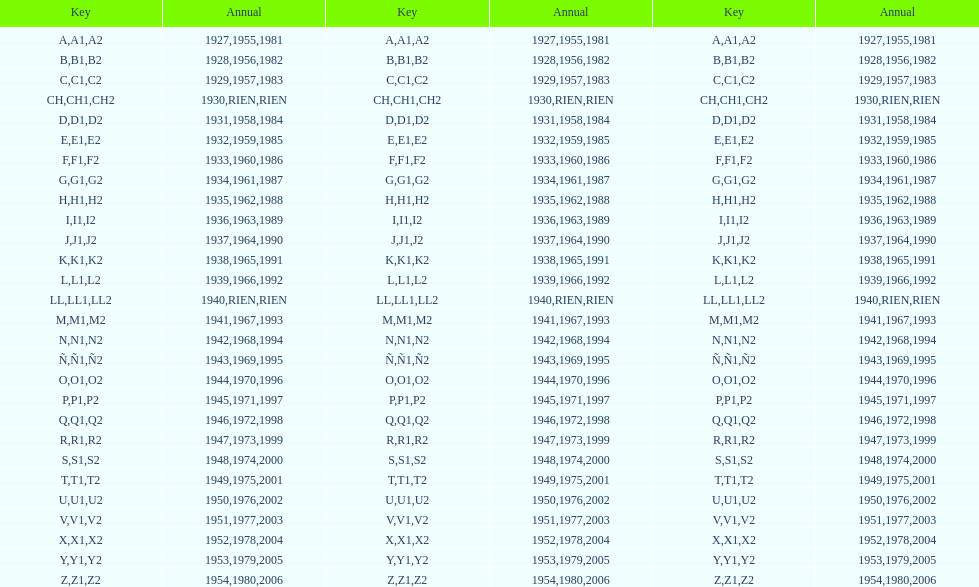Can you give me this table as a dict? {'header': ['Key', 'Annual', 'Key', 'Annual', 'Key', 'Annual'], 'rows': [['A', '1927', 'A1', '1955', 'A2', '1981'], ['B', '1928', 'B1', '1956', 'B2', '1982'], ['C', '1929', 'C1', '1957', 'C2', '1983'], ['CH', '1930', 'CH1', 'RIEN', 'CH2', 'RIEN'], ['D', '1931', 'D1', '1958', 'D2', '1984'], ['E', '1932', 'E1', '1959', 'E2', '1985'], ['F', '1933', 'F1', '1960', 'F2', '1986'], ['G', '1934', 'G1', '1961', 'G2', '1987'], ['H', '1935', 'H1', '1962', 'H2', '1988'], ['I', '1936', 'I1', '1963', 'I2', '1989'], ['J', '1937', 'J1', '1964', 'J2', '1990'], ['K', '1938', 'K1', '1965', 'K2', '1991'], ['L', '1939', 'L1', '1966', 'L2', '1992'], ['LL', '1940', 'LL1', 'RIEN', 'LL2', 'RIEN'], ['M', '1941', 'M1', '1967', 'M2', '1993'], ['N', '1942', 'N1', '1968', 'N2', '1994'], ['Ñ', '1943', 'Ñ1', '1969', 'Ñ2', '1995'], ['O', '1944', 'O1', '1970', 'O2', '1996'], ['P', '1945', 'P1', '1971', 'P2', '1997'], ['Q', '1946', 'Q1', '1972', 'Q2', '1998'], ['R', '1947', 'R1', '1973', 'R2', '1999'], ['S', '1948', 'S1', '1974', 'S2', '2000'], ['T', '1949', 'T1', '1975', 'T2', '2001'], ['U', '1950', 'U1', '1976', 'U2', '2002'], ['V', '1951', 'V1', '1977', 'V2', '2003'], ['X', '1952', 'X1', '1978', 'X2', '2004'], ['Y', '1953', 'Y1', '1979', 'Y2', '2005'], ['Z', '1954', 'Z1', '1980', 'Z2', '2006']]} List each code not associated to a year. CH1, CH2, LL1, LL2. 